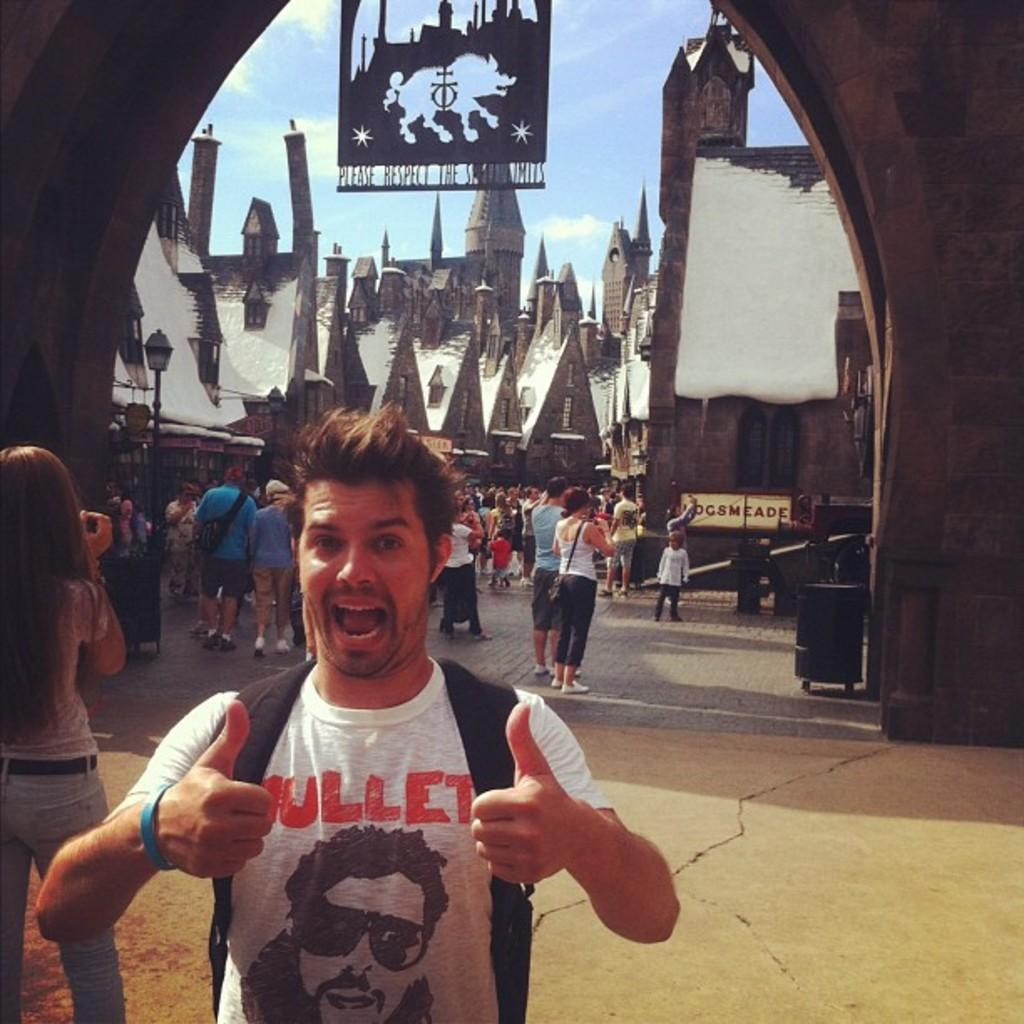How many people are present in the image? There are many people in the image. What are some people doing in the image? Some people are wearing bags, and one person is holding a camera. What can be seen in the background of the image? There are buildings in the background of the image. What is the reason for the church being present in the image? There is no church present in the image; it only features people and buildings in the background. 